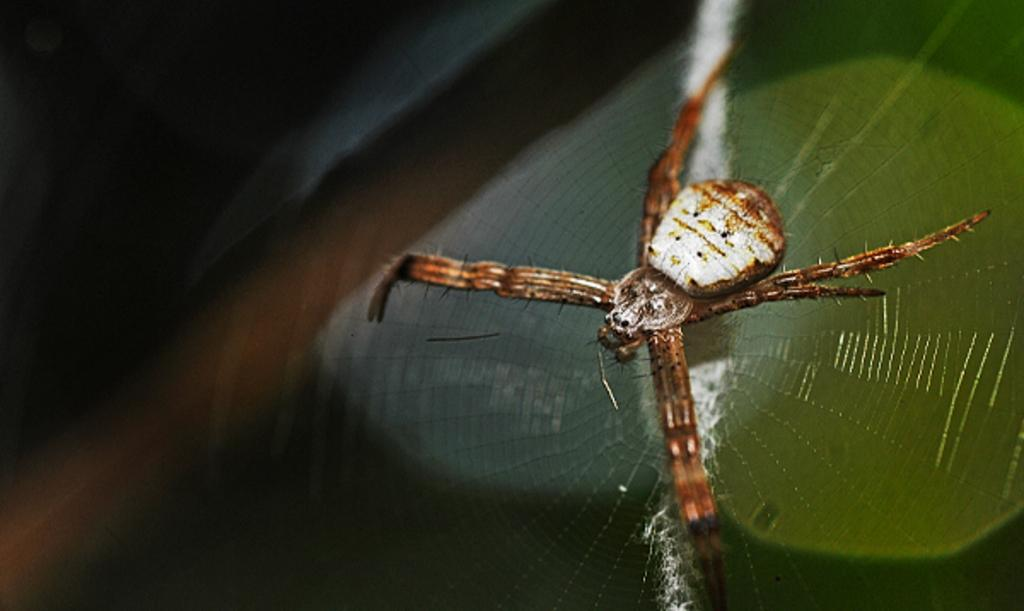What type of animal can be seen in the image? There is a brown spider in the image. Where is the spider located? The spider is sitting on a green leaf. Can you describe the background of the image? The background of the image is blurred. What type of roll is the monkey eating in the image? There is no monkey or roll present in the image; it features a brown spider sitting on a green leaf. 